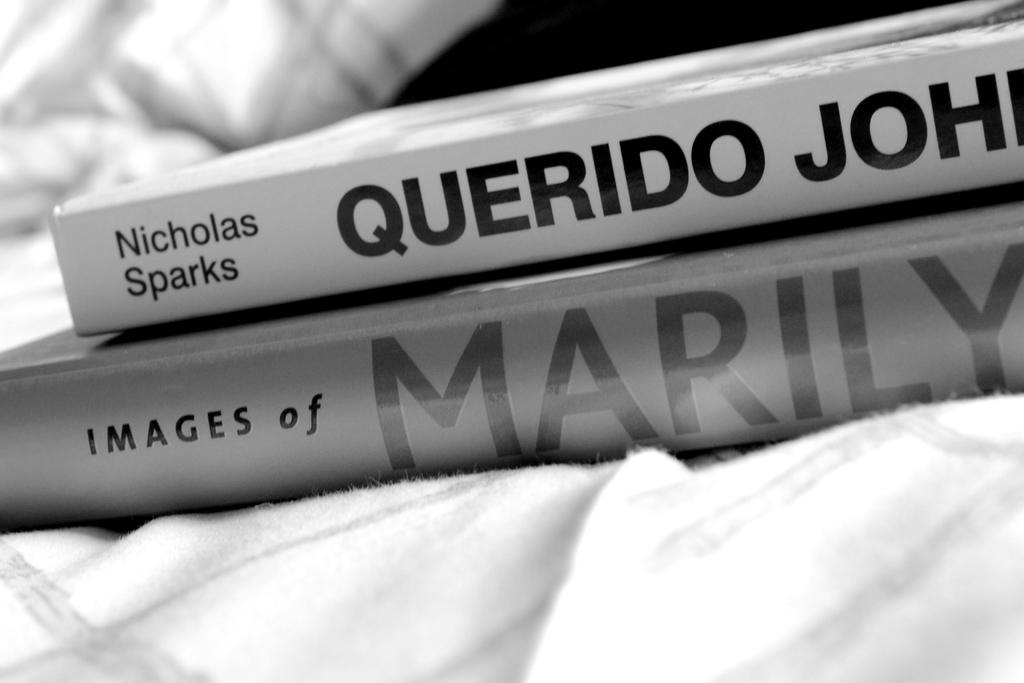What are the two words before marilyn on the second book?
Keep it short and to the point. Images of. 